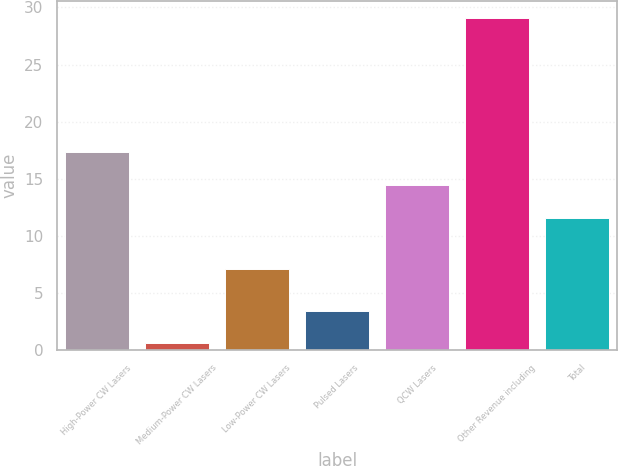<chart> <loc_0><loc_0><loc_500><loc_500><bar_chart><fcel>High-Power CW Lasers<fcel>Medium-Power CW Lasers<fcel>Low-Power CW Lasers<fcel>Pulsed Lasers<fcel>QCW Lasers<fcel>Other Revenue including<fcel>Total<nl><fcel>17.3<fcel>0.6<fcel>7.1<fcel>3.45<fcel>14.45<fcel>29.1<fcel>11.6<nl></chart> 